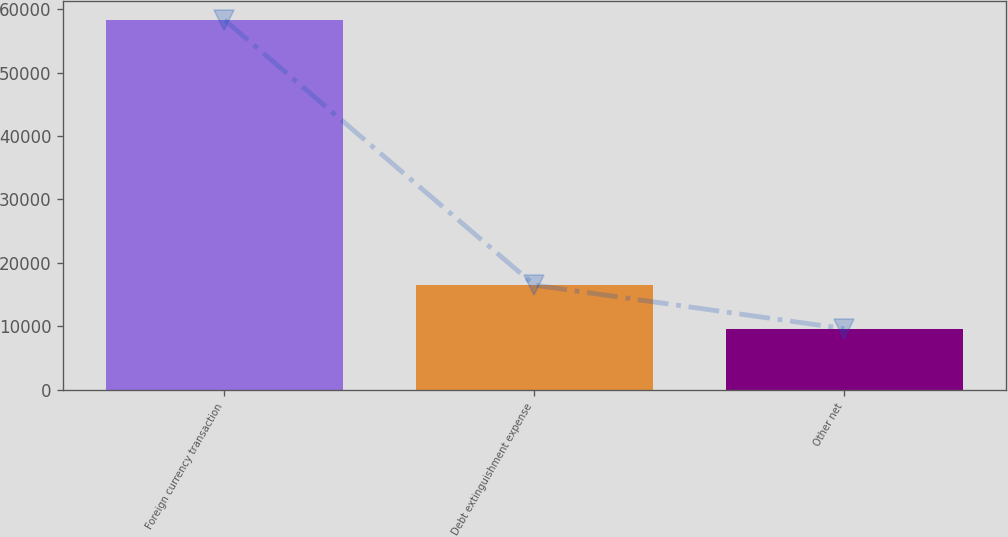Convert chart to OTSL. <chart><loc_0><loc_0><loc_500><loc_500><bar_chart><fcel>Foreign currency transaction<fcel>Debt extinguishment expense<fcel>Other net<nl><fcel>58316<fcel>16495<fcel>9624<nl></chart> 